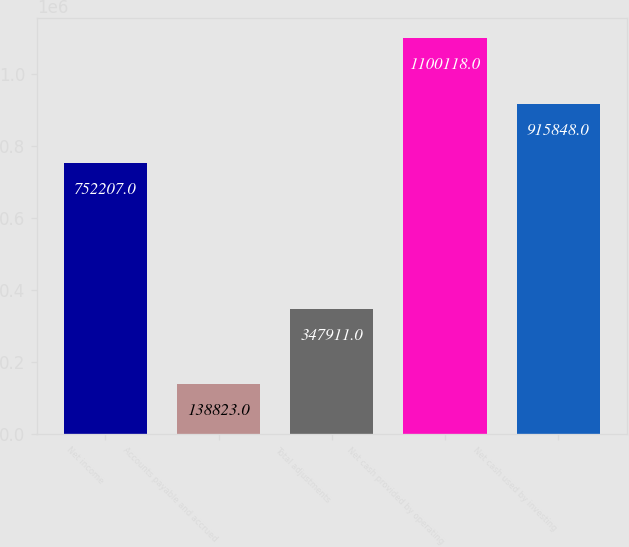Convert chart to OTSL. <chart><loc_0><loc_0><loc_500><loc_500><bar_chart><fcel>Net income<fcel>Accounts payable and accrued<fcel>Total adjustments<fcel>Net cash provided by operating<fcel>Net cash used by investing<nl><fcel>752207<fcel>138823<fcel>347911<fcel>1.10012e+06<fcel>915848<nl></chart> 